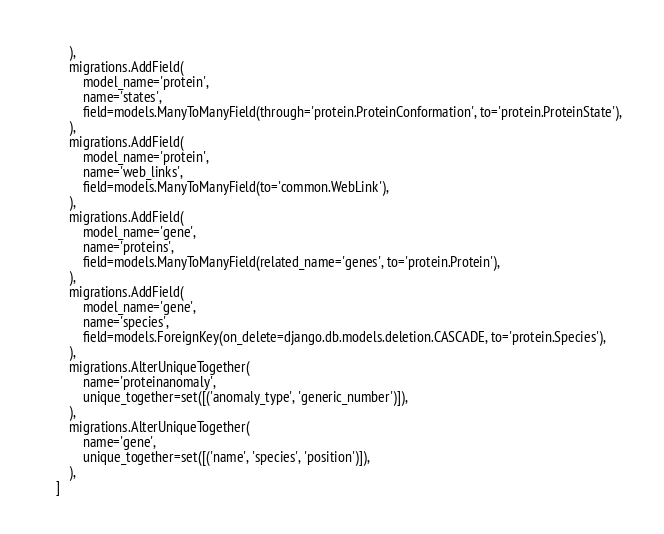Convert code to text. <code><loc_0><loc_0><loc_500><loc_500><_Python_>        ),
        migrations.AddField(
            model_name='protein',
            name='states',
            field=models.ManyToManyField(through='protein.ProteinConformation', to='protein.ProteinState'),
        ),
        migrations.AddField(
            model_name='protein',
            name='web_links',
            field=models.ManyToManyField(to='common.WebLink'),
        ),
        migrations.AddField(
            model_name='gene',
            name='proteins',
            field=models.ManyToManyField(related_name='genes', to='protein.Protein'),
        ),
        migrations.AddField(
            model_name='gene',
            name='species',
            field=models.ForeignKey(on_delete=django.db.models.deletion.CASCADE, to='protein.Species'),
        ),
        migrations.AlterUniqueTogether(
            name='proteinanomaly',
            unique_together=set([('anomaly_type', 'generic_number')]),
        ),
        migrations.AlterUniqueTogether(
            name='gene',
            unique_together=set([('name', 'species', 'position')]),
        ),
    ]
</code> 